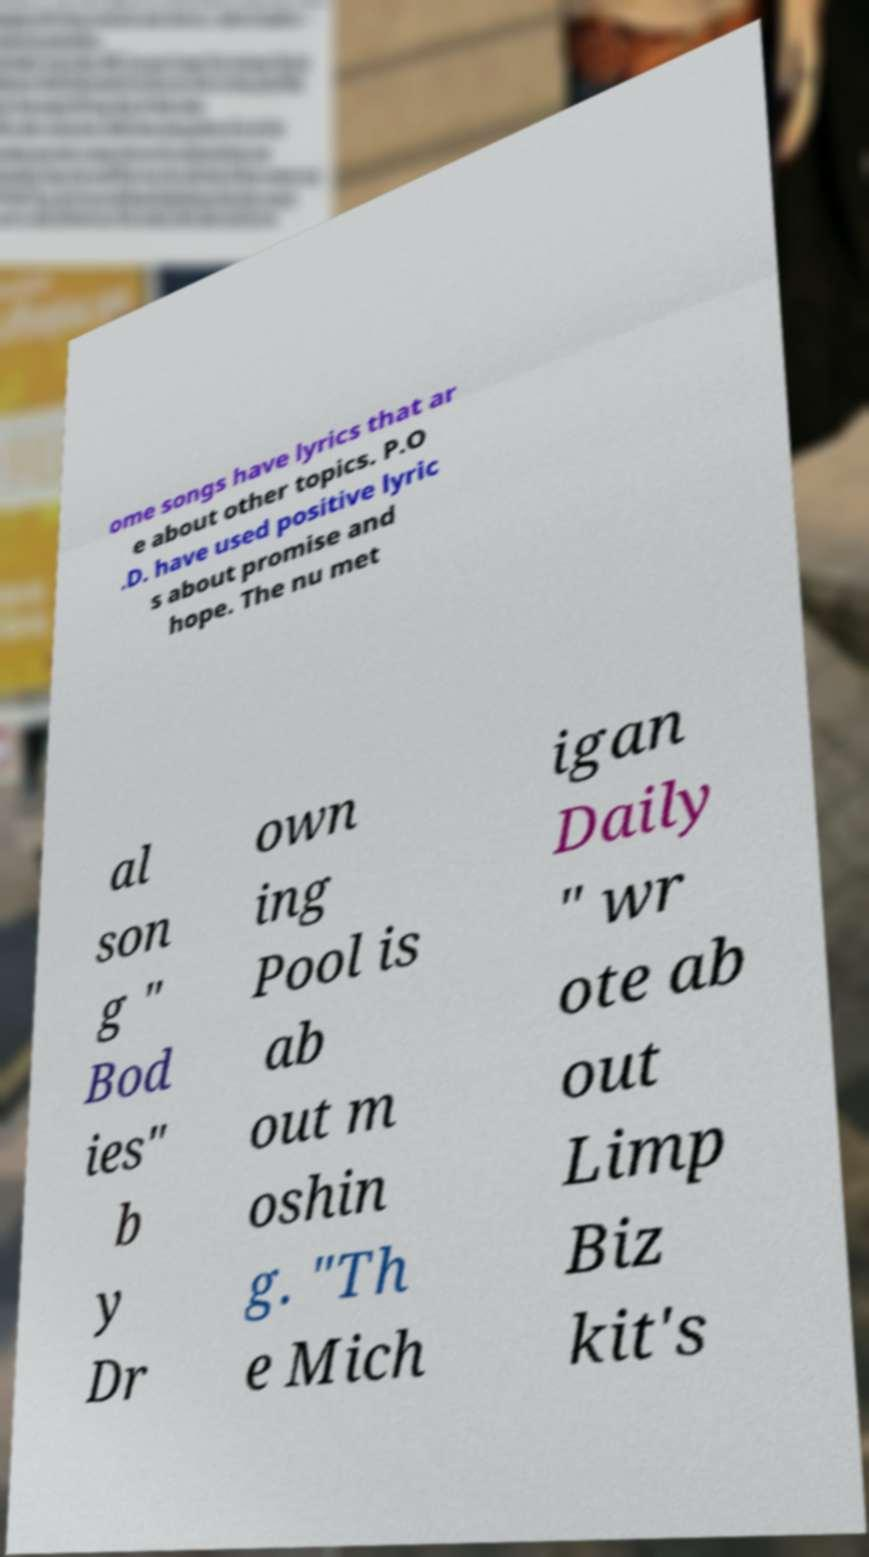What messages or text are displayed in this image? I need them in a readable, typed format. ome songs have lyrics that ar e about other topics. P.O .D. have used positive lyric s about promise and hope. The nu met al son g " Bod ies" b y Dr own ing Pool is ab out m oshin g. "Th e Mich igan Daily " wr ote ab out Limp Biz kit's 